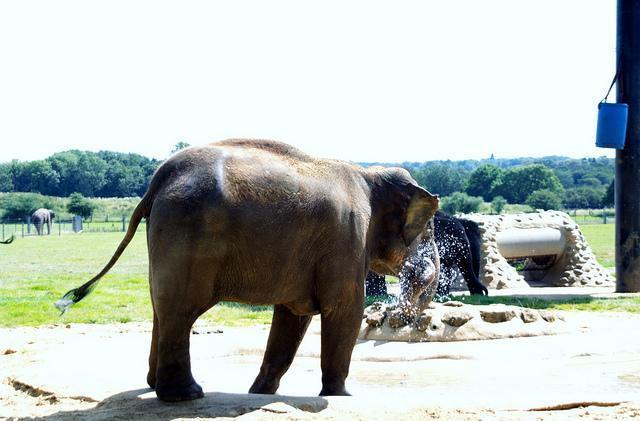How many elephants are visible?
Give a very brief answer. 2. 